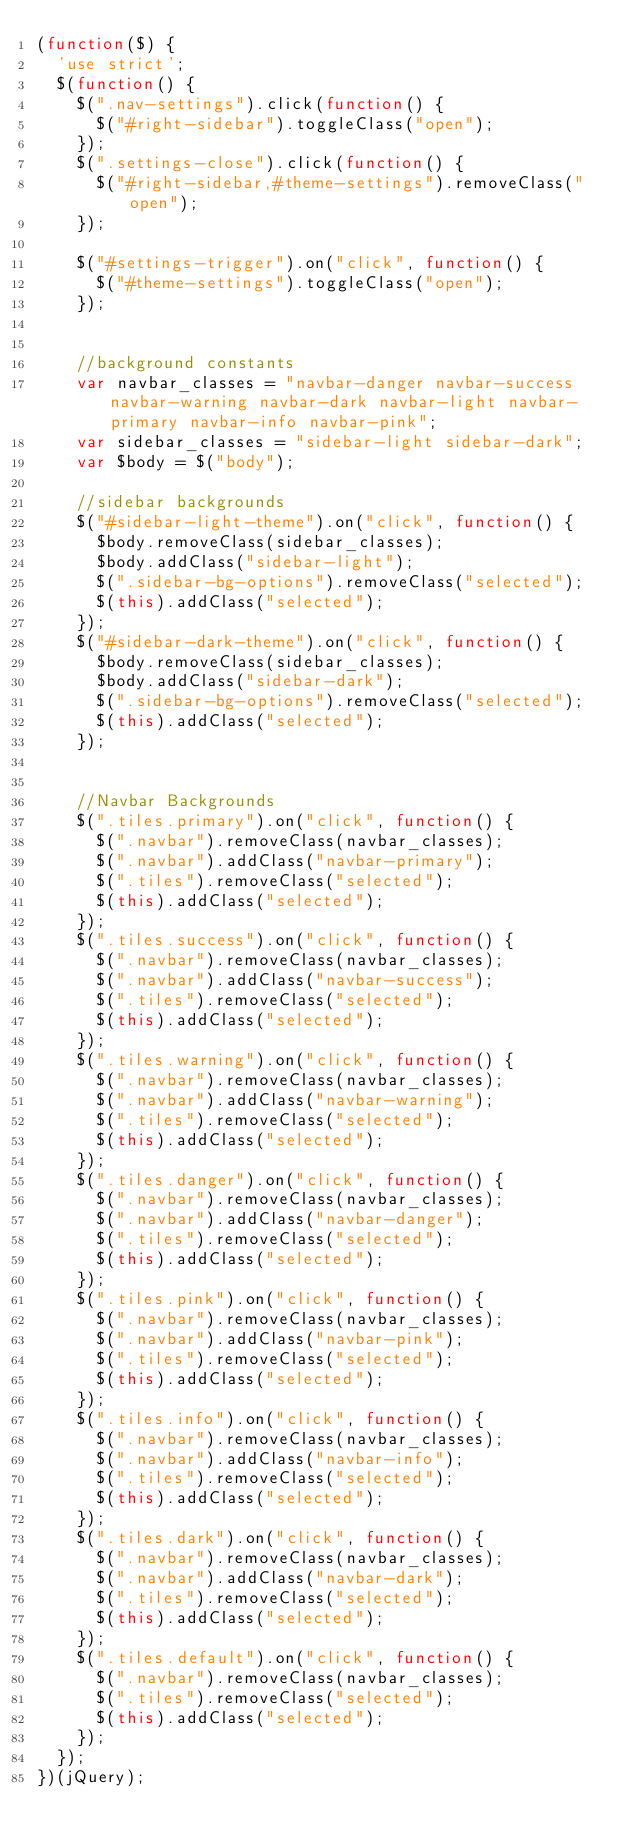<code> <loc_0><loc_0><loc_500><loc_500><_JavaScript_>(function($) {
  'use strict';
  $(function() {
    $(".nav-settings").click(function() {
      $("#right-sidebar").toggleClass("open");
    });
    $(".settings-close").click(function() {
      $("#right-sidebar,#theme-settings").removeClass("open");
    });

    $("#settings-trigger").on("click", function() {
      $("#theme-settings").toggleClass("open");
    });


    //background constants
    var navbar_classes = "navbar-danger navbar-success navbar-warning navbar-dark navbar-light navbar-primary navbar-info navbar-pink";
    var sidebar_classes = "sidebar-light sidebar-dark";
    var $body = $("body");

    //sidebar backgrounds
    $("#sidebar-light-theme").on("click", function() {
      $body.removeClass(sidebar_classes);
      $body.addClass("sidebar-light");
      $(".sidebar-bg-options").removeClass("selected");
      $(this).addClass("selected");
    });
    $("#sidebar-dark-theme").on("click", function() {
      $body.removeClass(sidebar_classes);
      $body.addClass("sidebar-dark");
      $(".sidebar-bg-options").removeClass("selected");
      $(this).addClass("selected");
    });


    //Navbar Backgrounds
    $(".tiles.primary").on("click", function() {
      $(".navbar").removeClass(navbar_classes);
      $(".navbar").addClass("navbar-primary");
      $(".tiles").removeClass("selected");
      $(this).addClass("selected");
    });
    $(".tiles.success").on("click", function() {
      $(".navbar").removeClass(navbar_classes);
      $(".navbar").addClass("navbar-success");
      $(".tiles").removeClass("selected");
      $(this).addClass("selected");
    });
    $(".tiles.warning").on("click", function() {
      $(".navbar").removeClass(navbar_classes);
      $(".navbar").addClass("navbar-warning");
      $(".tiles").removeClass("selected");
      $(this).addClass("selected");
    });
    $(".tiles.danger").on("click", function() {
      $(".navbar").removeClass(navbar_classes);
      $(".navbar").addClass("navbar-danger");
      $(".tiles").removeClass("selected");
      $(this).addClass("selected");
    });
    $(".tiles.pink").on("click", function() {
      $(".navbar").removeClass(navbar_classes);
      $(".navbar").addClass("navbar-pink");
      $(".tiles").removeClass("selected");
      $(this).addClass("selected");
    });
    $(".tiles.info").on("click", function() {
      $(".navbar").removeClass(navbar_classes);
      $(".navbar").addClass("navbar-info");
      $(".tiles").removeClass("selected");
      $(this).addClass("selected");
    });
    $(".tiles.dark").on("click", function() {
      $(".navbar").removeClass(navbar_classes);
      $(".navbar").addClass("navbar-dark");
      $(".tiles").removeClass("selected");
      $(this).addClass("selected");
    });
    $(".tiles.default").on("click", function() {
      $(".navbar").removeClass(navbar_classes);
      $(".tiles").removeClass("selected");
      $(this).addClass("selected");
    });
  });
})(jQuery);</code> 